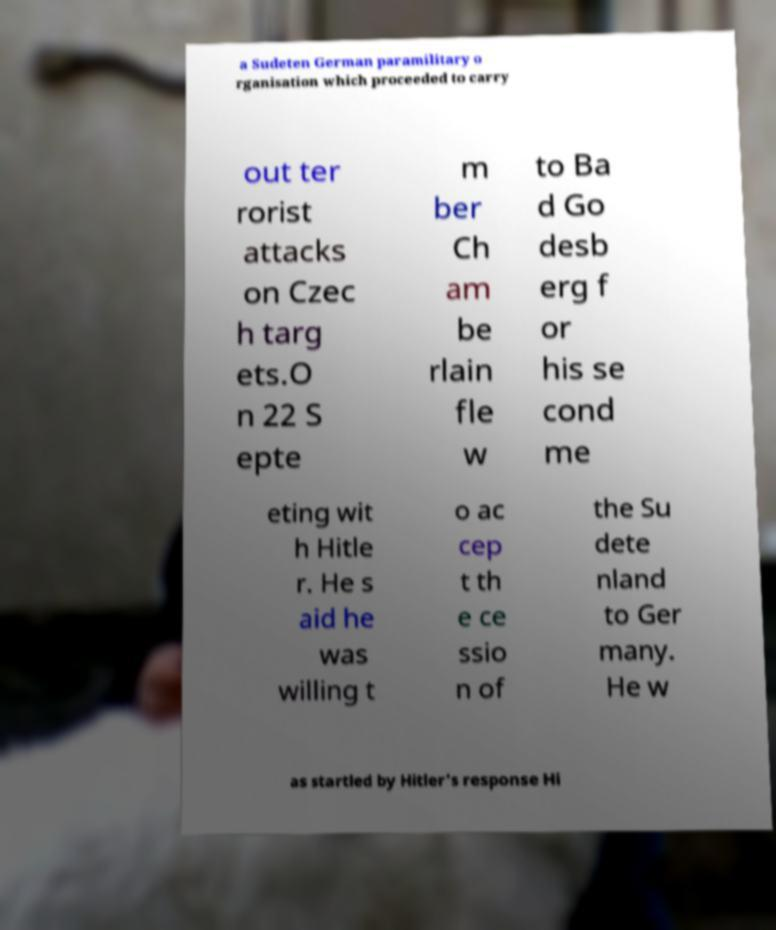Can you read and provide the text displayed in the image?This photo seems to have some interesting text. Can you extract and type it out for me? a Sudeten German paramilitary o rganisation which proceeded to carry out ter rorist attacks on Czec h targ ets.O n 22 S epte m ber Ch am be rlain fle w to Ba d Go desb erg f or his se cond me eting wit h Hitle r. He s aid he was willing t o ac cep t th e ce ssio n of the Su dete nland to Ger many. He w as startled by Hitler's response Hi 